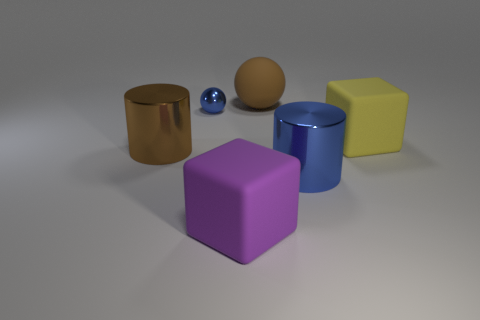Add 2 small blue balls. How many objects exist? 8 Subtract all cylinders. How many objects are left? 4 Subtract 1 purple blocks. How many objects are left? 5 Subtract all large brown balls. Subtract all matte things. How many objects are left? 2 Add 5 big purple objects. How many big purple objects are left? 6 Add 6 big purple rubber things. How many big purple rubber things exist? 7 